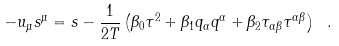<formula> <loc_0><loc_0><loc_500><loc_500>- u _ { \mu } s ^ { \mu } = s - \frac { 1 } { 2 T } \left ( \beta _ { 0 } \tau ^ { 2 } + \beta _ { 1 } q _ { \alpha } q ^ { \alpha } + \beta _ { 2 } \tau _ { \alpha \beta } \tau ^ { \alpha \beta } \right ) \ .</formula> 